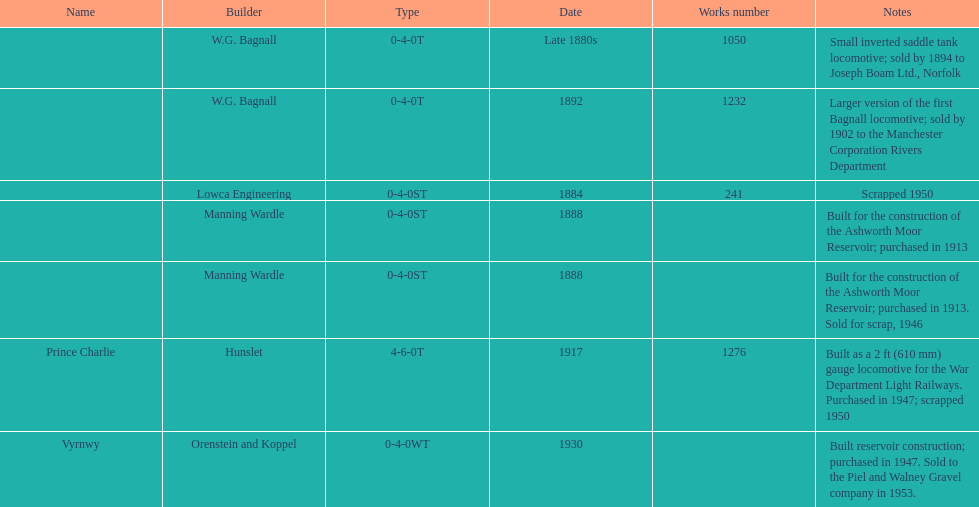Which locomotive maker assembled a locomotive after 1888 and built it as a 2ft gauge locomotive? Hunslet. 